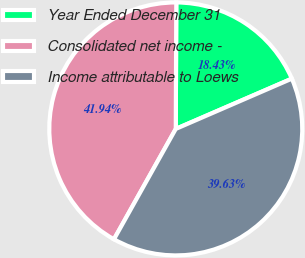Convert chart. <chart><loc_0><loc_0><loc_500><loc_500><pie_chart><fcel>Year Ended December 31<fcel>Consolidated net income -<fcel>Income attributable to Loews<nl><fcel>18.43%<fcel>41.94%<fcel>39.63%<nl></chart> 